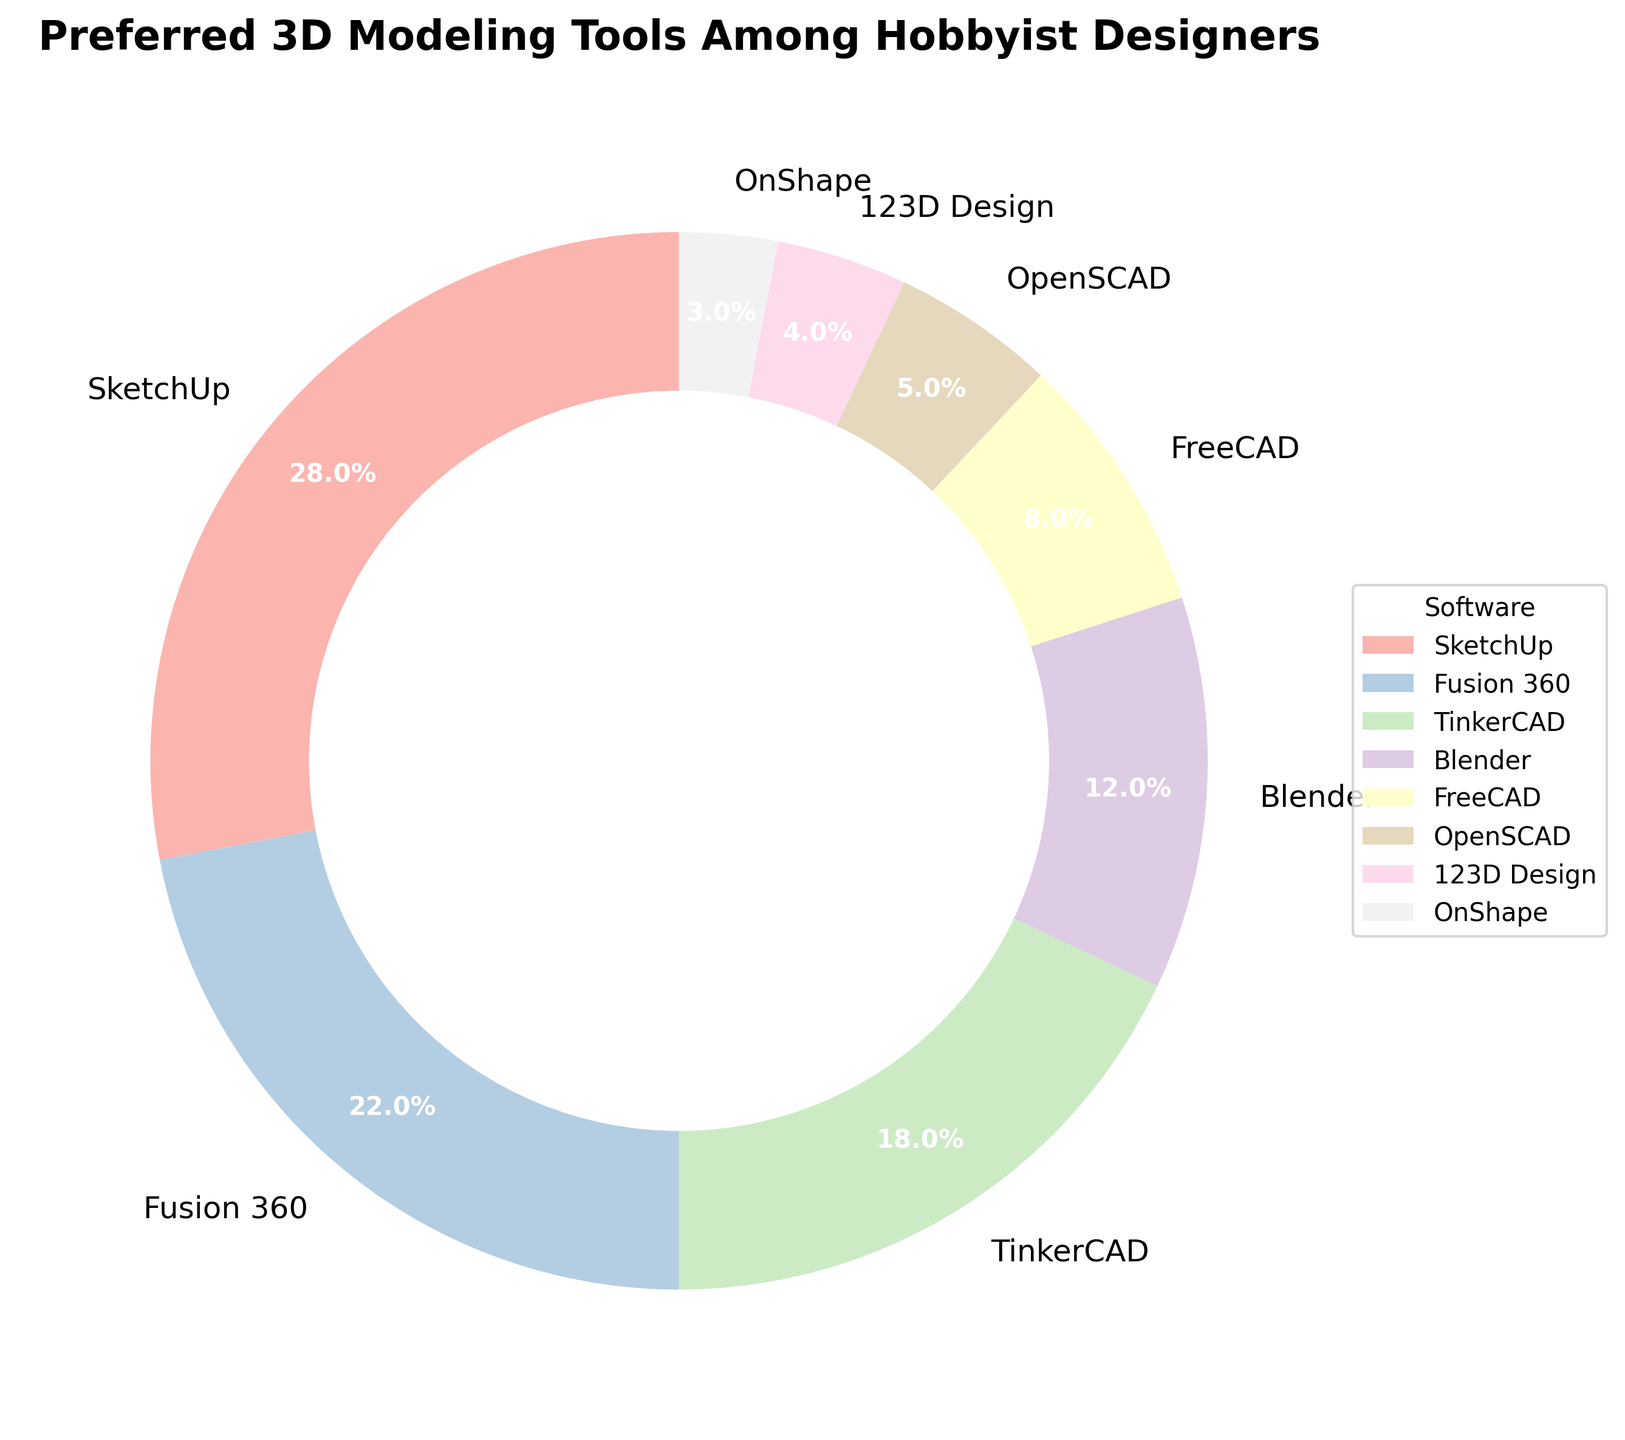Which software has the largest share among hobbyist designers? The pie chart shows that SketchUp has the largest percentage, which is 28%.
Answer: SketchUp Which two software tools together make up exactly half of the preferences? Adding the percentages of SketchUp (28%) and Fusion 360 (22%), we get 50%.
Answer: SketchUp and Fusion 360 What is the total percentage of software preferences occupied by Blender and FreeCAD? Adding the percentages of Blender (12%) and FreeCAD (8%), we get 20%.
Answer: 20% Which software has the smallest share among hobbyist designers? The pie chart displays that OnShape has the smallest percentage, which is 3%.
Answer: OnShape How does the share of TinkerCAD compare to that of Blender? TinkerCAD's share (18%) is larger than Blender's share (12%).
Answer: TinkerCAD > Blender Which color represents Fusion 360 in the pie chart? Refer to the legend to see that Fusion 360 is represented by its respective color in the chart. The exact color may vary due to the color map used.
Answer: Pastel color (specific color not determinable from text) How much greater is the percentage of SketchUp compared to OpenSCAD? SketchUp is 28% and OpenSCAD is 5%. The difference is 28% - 5% = 23%.
Answer: 23% What is the combined percentage of all the software shown in the pie chart except for SketchUp? Adding the percentages of all tools except SketchUp: Fusion 360 (22%) + TinkerCAD (18%) + Blender (12%) + FreeCAD (8%) + OpenSCAD (5%) + 123D Design (4%) + OnShape (3%) = 72%.
Answer: 72% Which software tools constitute less than 10% of the preferences each? FreeCAD (8%), OpenSCAD (5%), 123D Design (4%), and OnShape (3%) each constitute less than 10% of the preferences.
Answer: FreeCAD, OpenSCAD, 123D Design, OnShape If you combine the shares of the two least preferred software, what percentage do you get? Adding the percentages of 123D Design (4%) and OnShape (3%), we get 7%.
Answer: 7% 